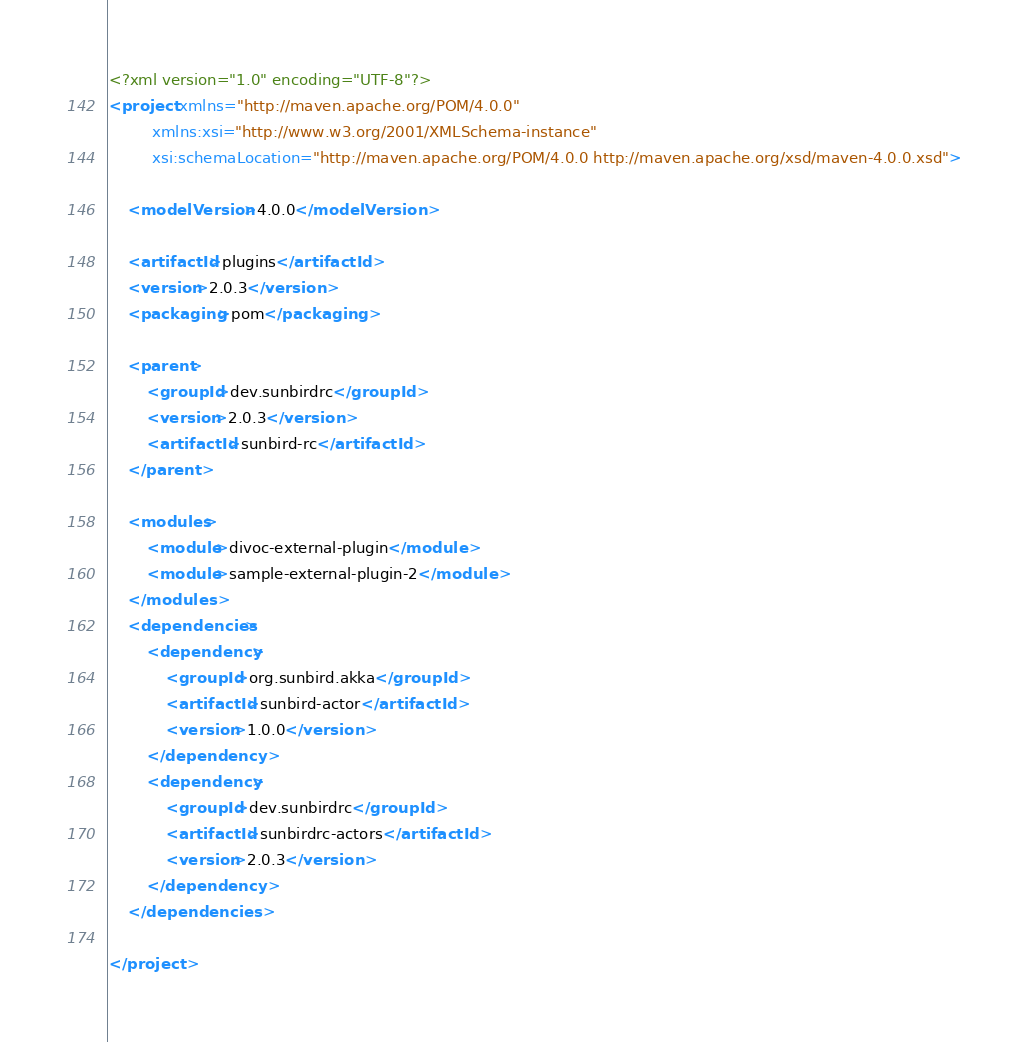<code> <loc_0><loc_0><loc_500><loc_500><_XML_><?xml version="1.0" encoding="UTF-8"?>
<project xmlns="http://maven.apache.org/POM/4.0.0"
         xmlns:xsi="http://www.w3.org/2001/XMLSchema-instance"
         xsi:schemaLocation="http://maven.apache.org/POM/4.0.0 http://maven.apache.org/xsd/maven-4.0.0.xsd">

    <modelVersion>4.0.0</modelVersion>

    <artifactId>plugins</artifactId>
    <version>2.0.3</version>
    <packaging>pom</packaging>

    <parent>
        <groupId>dev.sunbirdrc</groupId>
        <version>2.0.3</version>
        <artifactId>sunbird-rc</artifactId>
    </parent>

    <modules>
        <module>divoc-external-plugin</module>
        <module>sample-external-plugin-2</module>
    </modules>
    <dependencies>
        <dependency>
            <groupId>org.sunbird.akka</groupId>
            <artifactId>sunbird-actor</artifactId>
            <version>1.0.0</version>
        </dependency>
        <dependency>
            <groupId>dev.sunbirdrc</groupId>
            <artifactId>sunbirdrc-actors</artifactId>
            <version>2.0.3</version>
        </dependency>
    </dependencies>

</project></code> 